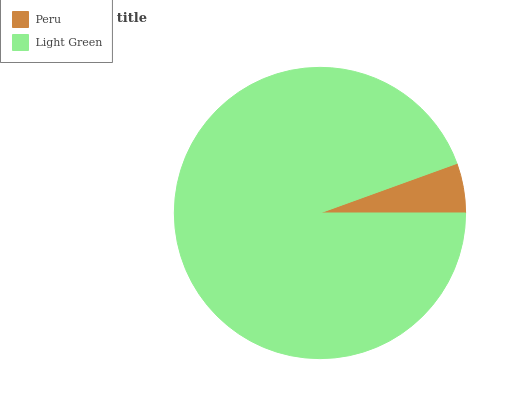Is Peru the minimum?
Answer yes or no. Yes. Is Light Green the maximum?
Answer yes or no. Yes. Is Light Green the minimum?
Answer yes or no. No. Is Light Green greater than Peru?
Answer yes or no. Yes. Is Peru less than Light Green?
Answer yes or no. Yes. Is Peru greater than Light Green?
Answer yes or no. No. Is Light Green less than Peru?
Answer yes or no. No. Is Light Green the high median?
Answer yes or no. Yes. Is Peru the low median?
Answer yes or no. Yes. Is Peru the high median?
Answer yes or no. No. Is Light Green the low median?
Answer yes or no. No. 